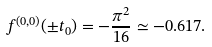Convert formula to latex. <formula><loc_0><loc_0><loc_500><loc_500>f ^ { ( 0 , 0 ) } ( \pm t _ { 0 } ) = - \frac { \pi ^ { 2 } } { 1 6 } \simeq - 0 . 6 1 7 .</formula> 